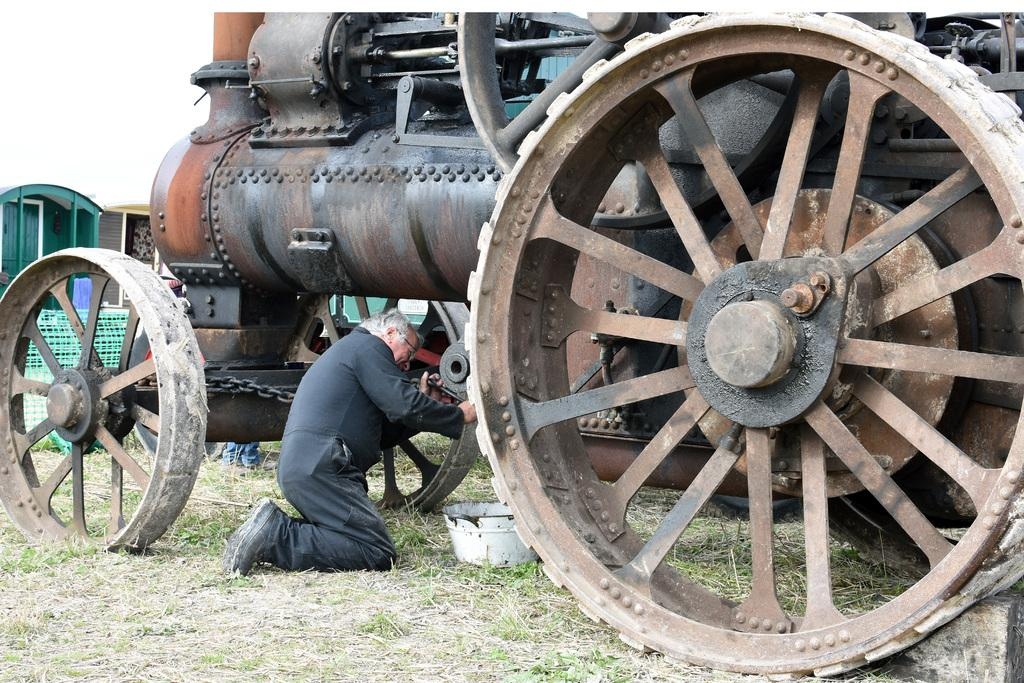What is the main subject in the image? There is a person in the image. What type of terrain is visible in the image? The ground with grass is visible in the image. What objects can be seen on the ground? There are some objects on the ground. What type of structures are present in the image? There are sheds in the image. What mode of transportation is present in the image? A train is present in the image. What part of the natural environment is visible in the image? The sky is visible in the image. Can you tell me how many doors are on the zoo in the image? There is no zoo present in the image, so it is not possible to determine the number of doors. What type of snake can be seen slithering on the ground in the image? There are no snakes present in the image; the ground has grass and some objects on it. 